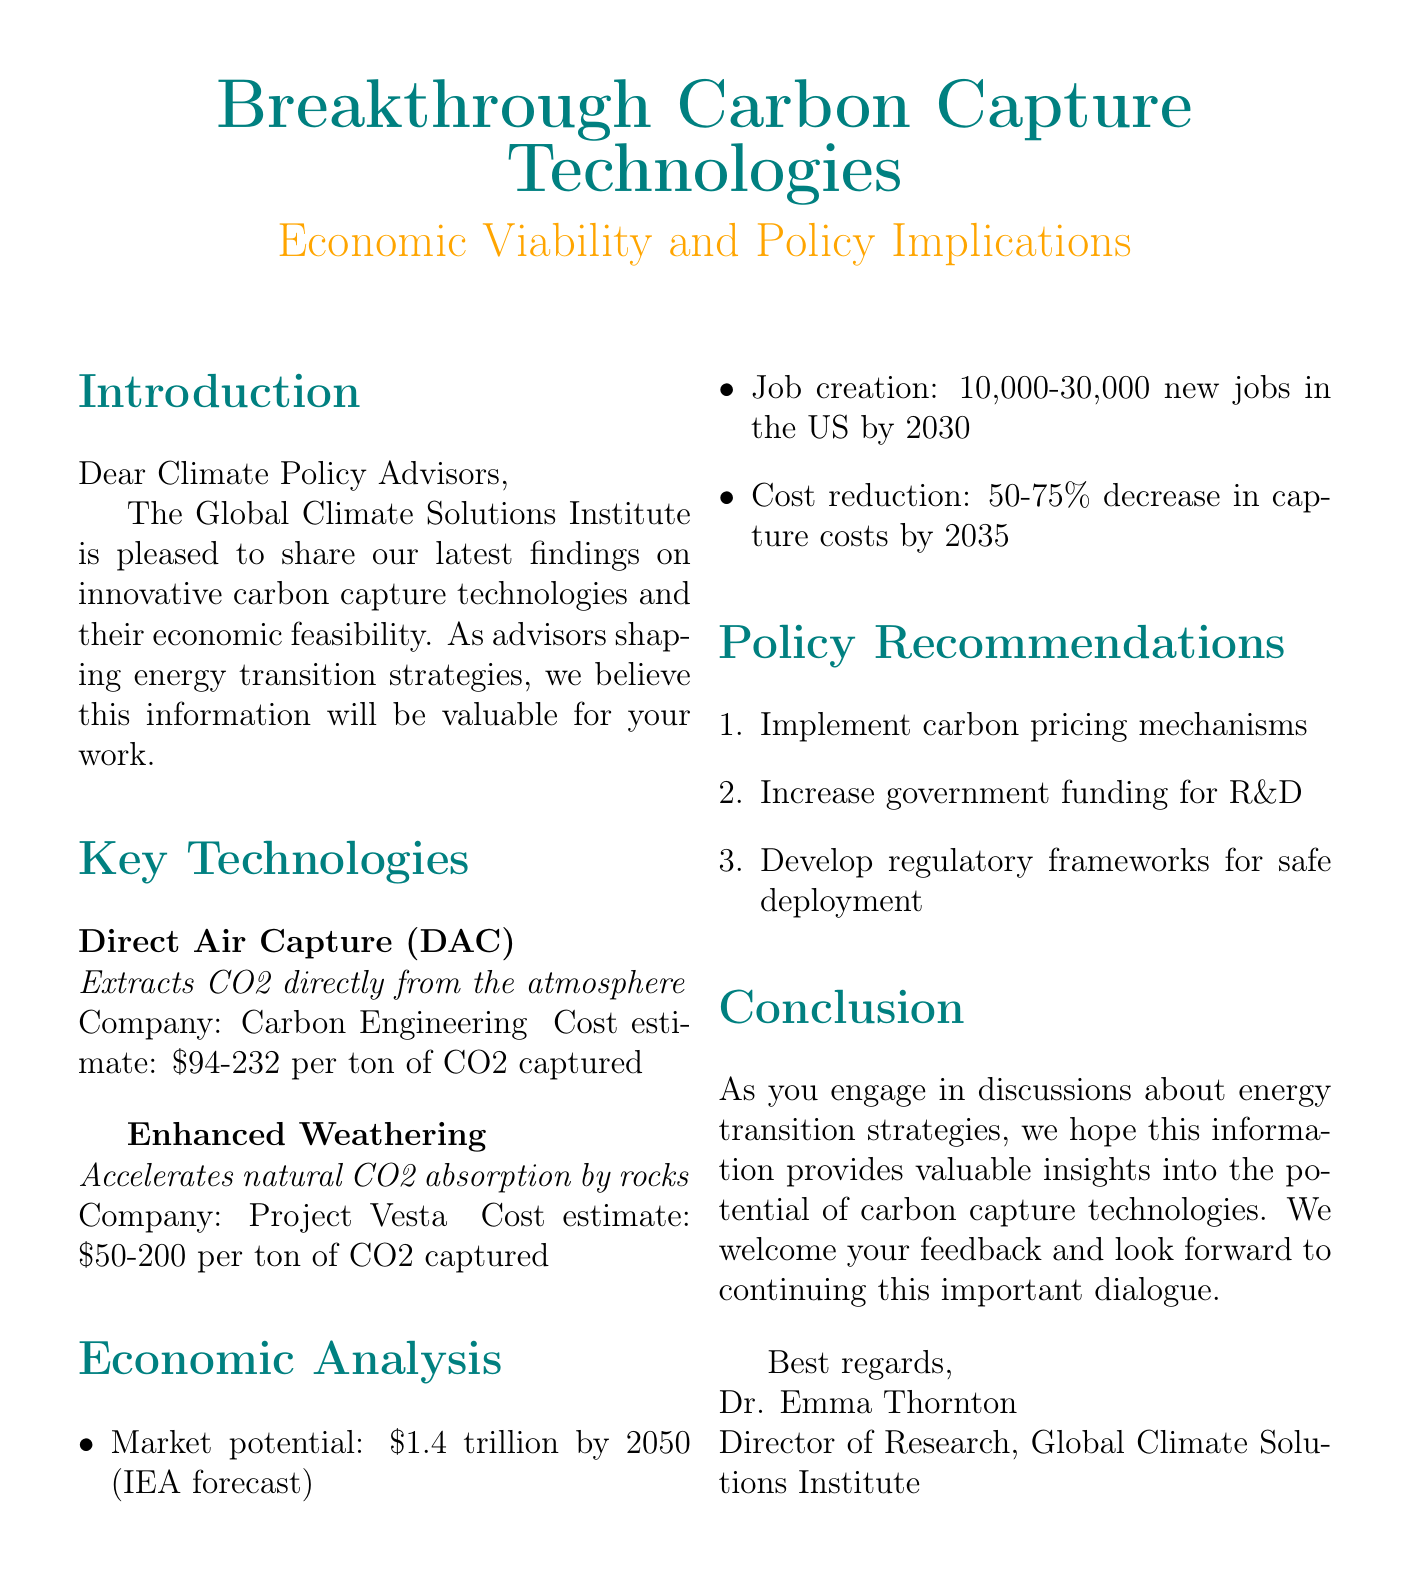What are the two key carbon capture technologies mentioned? The document lists Direct Air Capture and Enhanced Weathering as the two key technologies.
Answer: Direct Air Capture, Enhanced Weathering What is the cost estimate for Direct Air Capture? The document specifies the cost estimate range for Direct Air Capture as mentioned in the key technologies section.
Answer: $94-232 per ton of CO2 captured What is the forecasted market potential for carbon capture technologies by 2050? The market potential figure is provided in the economic analysis section, which projects the future market size.
Answer: $1.4 trillion How many new jobs are estimated to be created in the US by 2030? The document states an estimate of new jobs in the job creation section, providing a range.
Answer: 10,000-30,000 What is one policy recommendation made in the document? At least one recommendation is listed under the policy recommendations section, highlighting steps to encourage carbon capture technology adoption.
Answer: Implement carbon pricing mechanisms What is the expected decrease in capture costs by 2035? The document mentions a specific percentage decrease projected for capture costs due to advancements in technology.
Answer: 50-75% decrease Who is the author of the newsletter? The author's name and position are given at the conclusion of the document, specifying who is sharing the information.
Answer: Dr. Emma Thornton What organization is responsible for the findings shared in the document? The document states the organization that produced the research at the beginning.
Answer: Global Climate Solutions Institute 